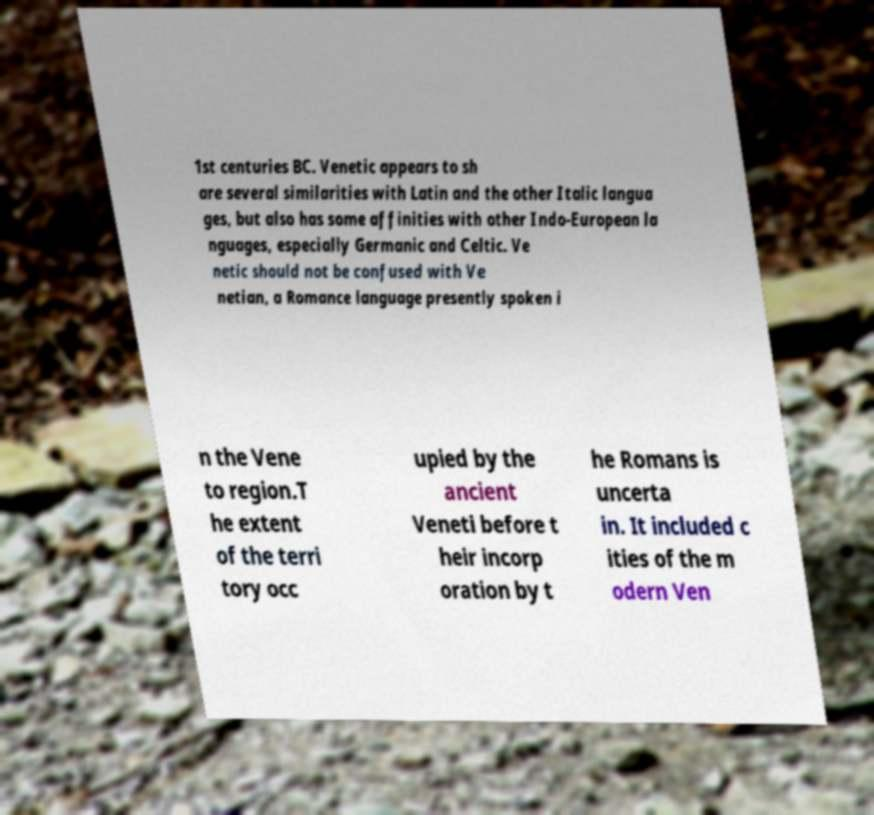Could you extract and type out the text from this image? 1st centuries BC. Venetic appears to sh are several similarities with Latin and the other Italic langua ges, but also has some affinities with other Indo-European la nguages, especially Germanic and Celtic. Ve netic should not be confused with Ve netian, a Romance language presently spoken i n the Vene to region.T he extent of the terri tory occ upied by the ancient Veneti before t heir incorp oration by t he Romans is uncerta in. It included c ities of the m odern Ven 